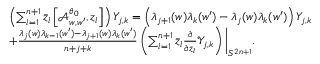Convert formula to latex. <formula><loc_0><loc_0><loc_500><loc_500>\begin{array} { r l } & { \left ( \sum _ { l = 1 } ^ { n + 1 } \bar { z } _ { l } \left [ \mathcal { A } _ { w , w ^ { \prime } } ^ { \theta _ { 0 } } , z _ { l } \right ] \right ) Y _ { j , k } = \left ( \lambda _ { j + 1 } ( w ) \lambda _ { k } ( w ^ { \prime } ) - \lambda _ { j } ( w ) \lambda _ { k } ( w ^ { \prime } ) \right ) Y _ { j , k } } \\ & { + \frac { \lambda _ { j } ( w ) \lambda _ { k - 1 } ( w ^ { \prime } ) - \lambda _ { j + 1 } ( w ) \lambda _ { k } ( w ^ { \prime } ) } { n + j + k } \left ( \sum _ { l = 1 } ^ { n + 1 } \bar { z } _ { l } \frac { \partial } { \partial \bar { z } _ { l } } \mathcal { Y } _ { j , k } \right ) \Big | _ { S ^ { 2 n + 1 } } . } \end{array}</formula> 